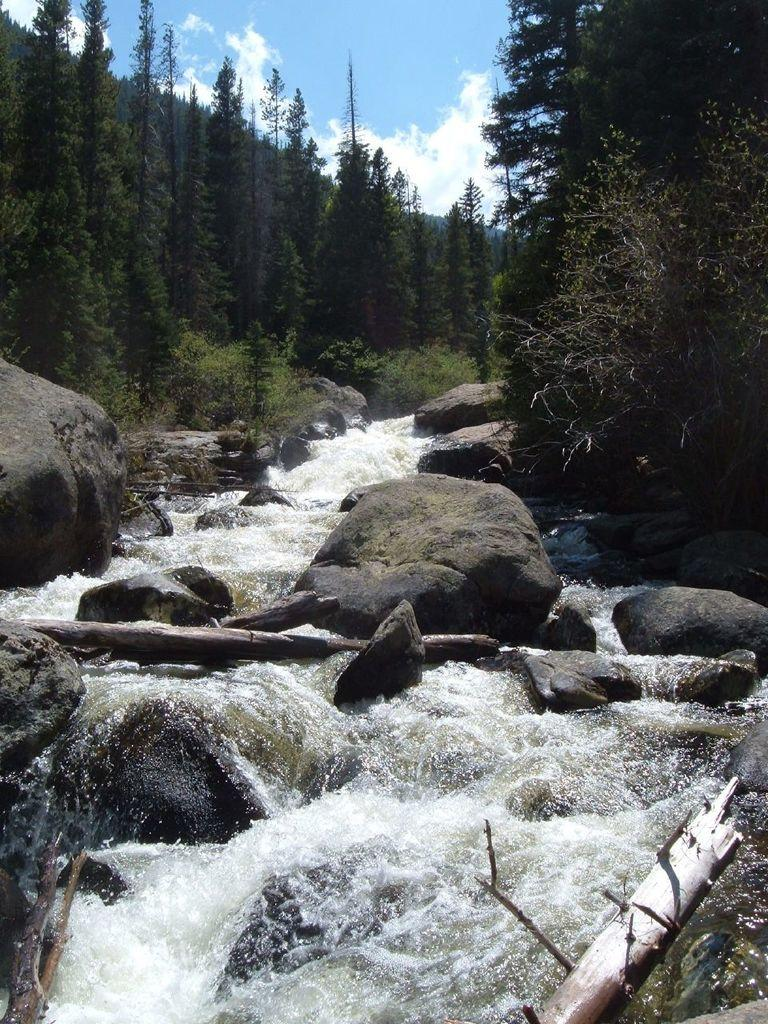What type of natural elements can be seen in the image? There are rocks and water flowing between the rocks in the image. What type of vegetation is present in the image? There are trees on either side of the image. What is visible at the top of the image? The sky is visible at the top of the image. Can you see a monkey playing with a stone in the image? There is no monkey or stone present in the image. What type of band is performing in the image? There is no band present in the image. 